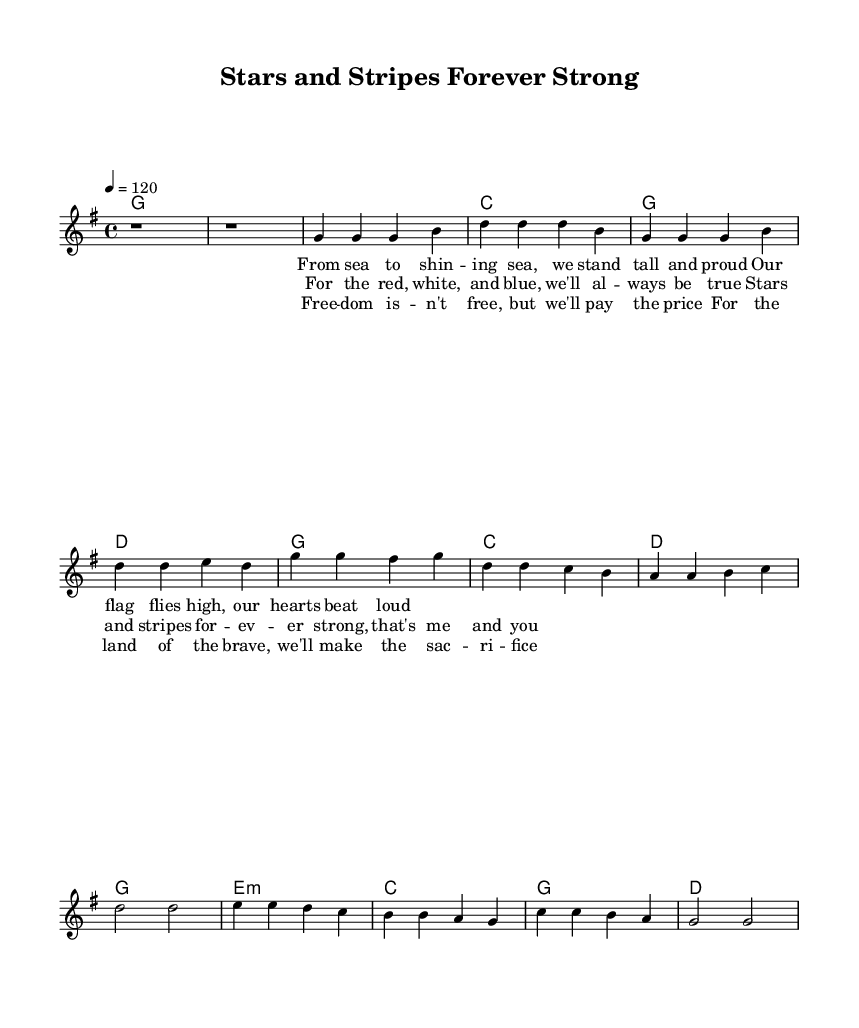What is the key signature of this music? The key signature is G major, which has one sharp (F#).
Answer: G major What is the time signature of the piece? The time signature shown in the music is 4/4, indicating there are four beats per measure.
Answer: 4/4 What is the tempo marking for this song? The tempo marking indicates a speed of 120 beats per minute, which helps determine how quickly the music should be played.
Answer: 120 How many measures are in the verse section? The verse consists of four measures, as indicated by the grouping of notes and rests in that section.
Answer: 4 Which chord is played during the chorus? The dominant chord used in the chorus is D major, specified in the harmonies section under the chorus line.
Answer: D major What is the theme addressed in the bridge lyrics? The theme in the bridge lyrics discusses the price of freedom and sacrifice for the country, reflecting patriotic sentiments common in country rock music.
Answer: Sacrifice for freedom What is the primary lyrical focus of the entire piece? The primary lyrical focus celebrates military service and American values, emphasizing pride in the nation's flag and commitment to freedom.
Answer: Patriotism 